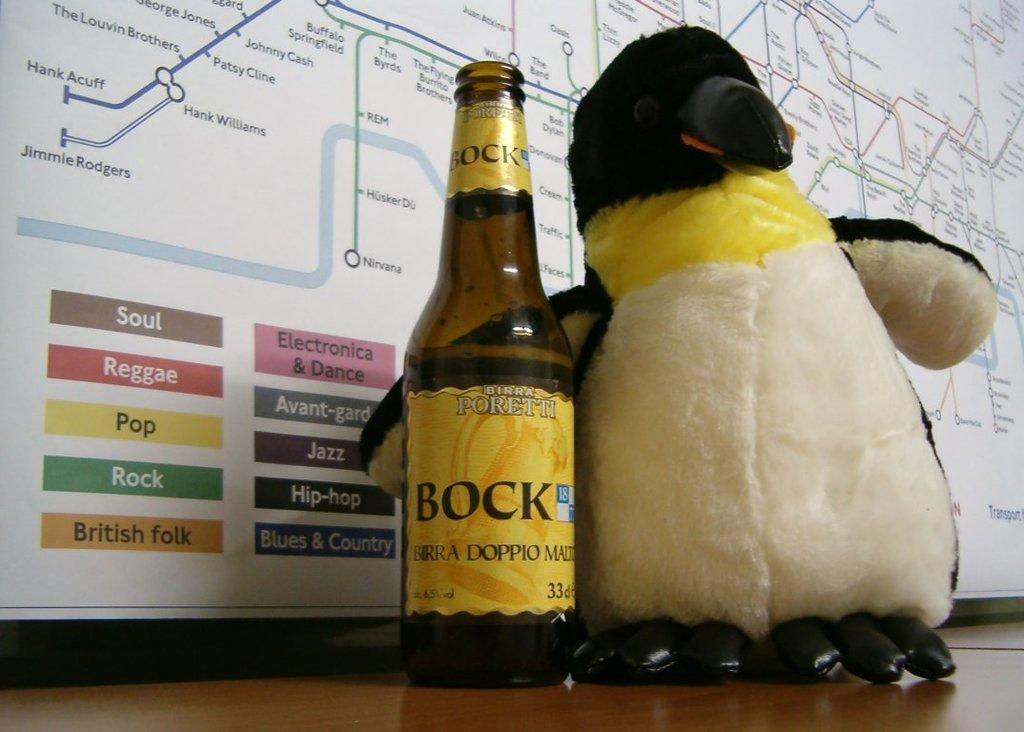What object in the image is typically used for play? There is a toy in the image, which is typically used for play. What object in the image is used for holding and dispensing liquids? There is a bottle in the image, which is used for holding and dispensing liquids. What type of item is displayed on the poster in the image? The poster in the image has the words "The soul," "reggae," "pop," "rock," and "British fork" written on it. What type of rabbit can be seen performing in the show on the poster? There is no rabbit or show mentioned on the poster; it only has the words "The soul," "reggae," "pop," "rock," and "British fork" written on it. 